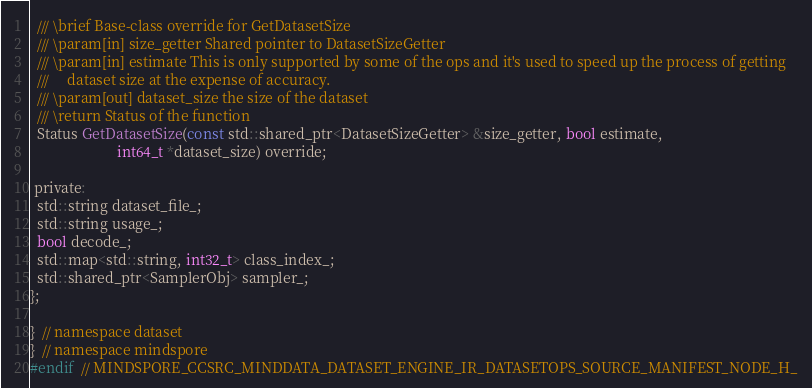Convert code to text. <code><loc_0><loc_0><loc_500><loc_500><_C_>
  /// \brief Base-class override for GetDatasetSize
  /// \param[in] size_getter Shared pointer to DatasetSizeGetter
  /// \param[in] estimate This is only supported by some of the ops and it's used to speed up the process of getting
  ///     dataset size at the expense of accuracy.
  /// \param[out] dataset_size the size of the dataset
  /// \return Status of the function
  Status GetDatasetSize(const std::shared_ptr<DatasetSizeGetter> &size_getter, bool estimate,
                        int64_t *dataset_size) override;

 private:
  std::string dataset_file_;
  std::string usage_;
  bool decode_;
  std::map<std::string, int32_t> class_index_;
  std::shared_ptr<SamplerObj> sampler_;
};

}  // namespace dataset
}  // namespace mindspore
#endif  // MINDSPORE_CCSRC_MINDDATA_DATASET_ENGINE_IR_DATASETOPS_SOURCE_MANIFEST_NODE_H_
</code> 